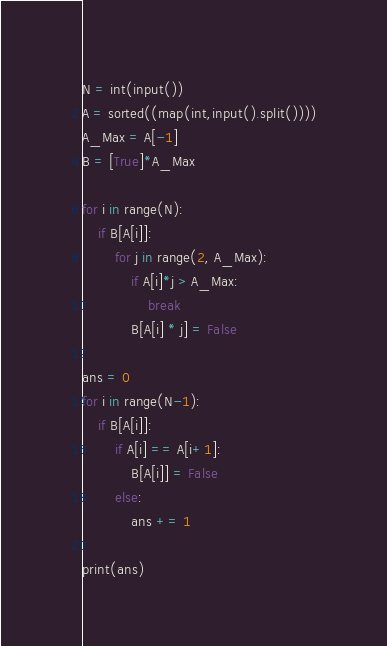Convert code to text. <code><loc_0><loc_0><loc_500><loc_500><_Python_>N = int(input())
A = sorted((map(int,input().split())))
A_Max = A[-1]
B = [True]*A_Max

for i in range(N):
    if B[A[i]]:
        for j in range(2, A_Max):
            if A[i]*j > A_Max:
                break
            B[A[i] * j] = False

ans = 0
for i in range(N-1):
    if B[A[i]]:
        if A[i] == A[i+1]:
            B[A[i]] = False
        else:
            ans += 1

print(ans)

</code> 